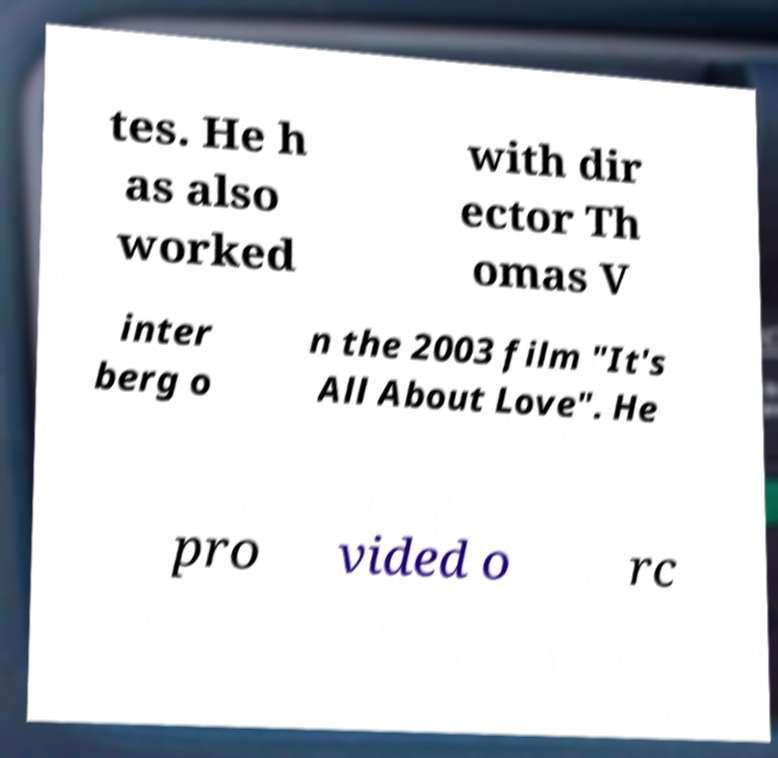Could you extract and type out the text from this image? tes. He h as also worked with dir ector Th omas V inter berg o n the 2003 film "It's All About Love". He pro vided o rc 